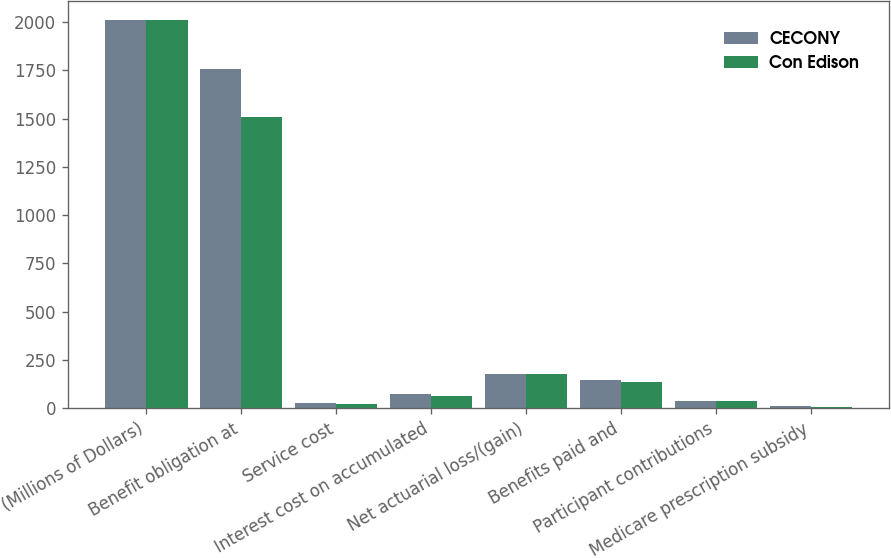Convert chart. <chart><loc_0><loc_0><loc_500><loc_500><stacked_bar_chart><ecel><fcel>(Millions of Dollars)<fcel>Benefit obligation at<fcel>Service cost<fcel>Interest cost on accumulated<fcel>Net actuarial loss/(gain)<fcel>Benefits paid and<fcel>Participant contributions<fcel>Medicare prescription subsidy<nl><fcel>CECONY<fcel>2012<fcel>1756<fcel>26<fcel>73<fcel>175<fcel>146<fcel>37<fcel>10<nl><fcel>Con Edison<fcel>2012<fcel>1511<fcel>21<fcel>63<fcel>178<fcel>134<fcel>36<fcel>8<nl></chart> 